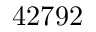<formula> <loc_0><loc_0><loc_500><loc_500>4 2 7 9 2</formula> 